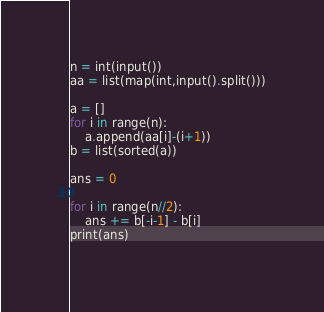Convert code to text. <code><loc_0><loc_0><loc_500><loc_500><_Python_>n = int(input())
aa = list(map(int,input().split()))

a = []
for i in range(n):
    a.append(aa[i]-(i+1))
b = list(sorted(a))

ans = 0

for i in range(n//2):
    ans += b[-i-1] - b[i]
print(ans)
    </code> 